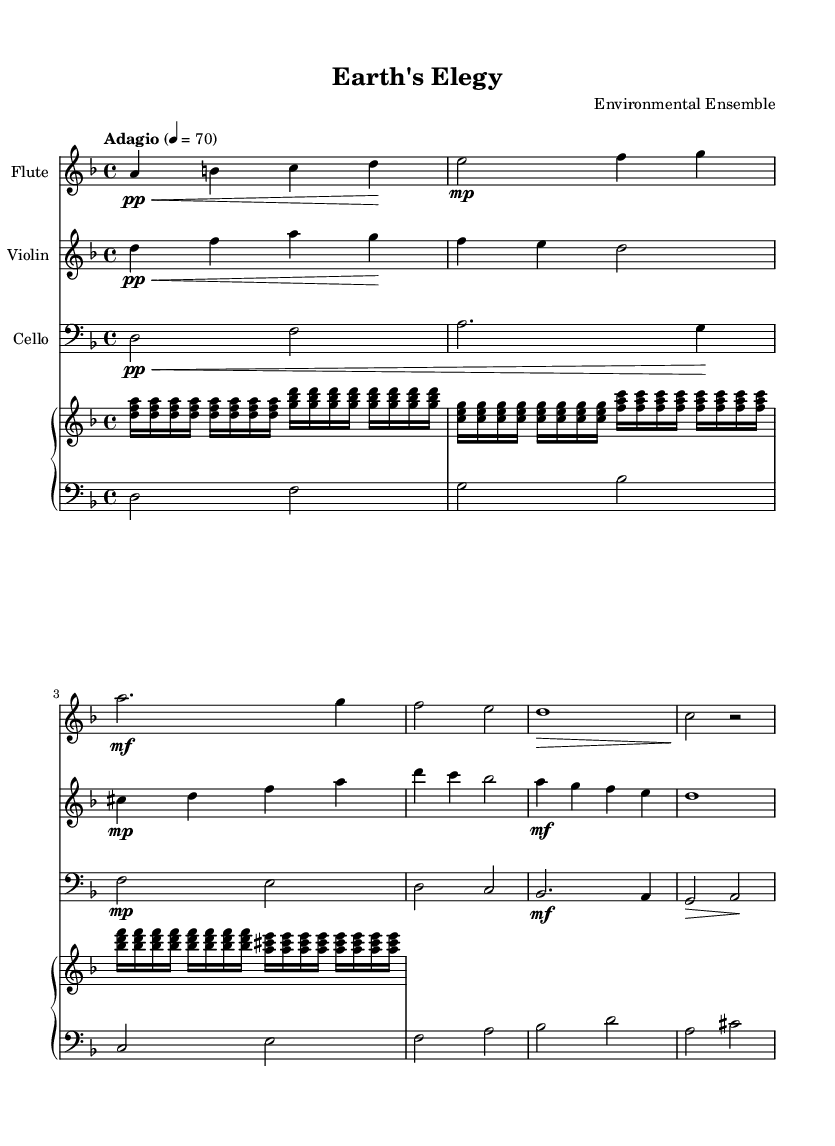What is the key signature of this music? The key signature is indicated by the sharp or flat symbols at the beginning of the staff. Here, it shows one flat, which corresponds to the key of D minor.
Answer: D minor What is the time signature of this music? The time signature can be found at the beginning of the staff, where it is represented by a fraction. In this case, it is 4/4, meaning there are four beats in each measure.
Answer: 4/4 What is the tempo marking for this piece? The tempo marking is written above the staff and gives the speed of the piece. In this example, it says "Adagio" with a metronome marking of 70 beats per minute.
Answer: Adagio, 70 Which instruments are featured in this composition? The instruments listed at the beginning of their respective staves indicate which instruments are used. Here, we see Flute, Violin, and Cello.
Answer: Flute, Violin, Cello What dynamics are indicated for the flute? The dynamics in the score are shown by various markings next to the notes, such as "pp" for pianissimo and "mp" for mezzo-piano. For the flute, it starts with "pp" and transitions to "mp".
Answer: pp, mp How does the texture of the piece change throughout the score? The texture involves the number and interaction of voices/instruments in the music. Starting with a solo flute, it gradually adds violin and cello, creating a denser texture as they intertwine. This shows a buildup reflecting urgency.
Answer: Gradually denser texture What musical elements evoke urgency in this piece? Elements such as the choice of minor key, fast rhythmic patterns in the right hand, dynamic contrasts, and the interweaving of the three instruments create a sense of tension and urgency, enhancing the message of climate change and environmental protection.
Answer: Minor key, dynamic contrasts, interweaving 